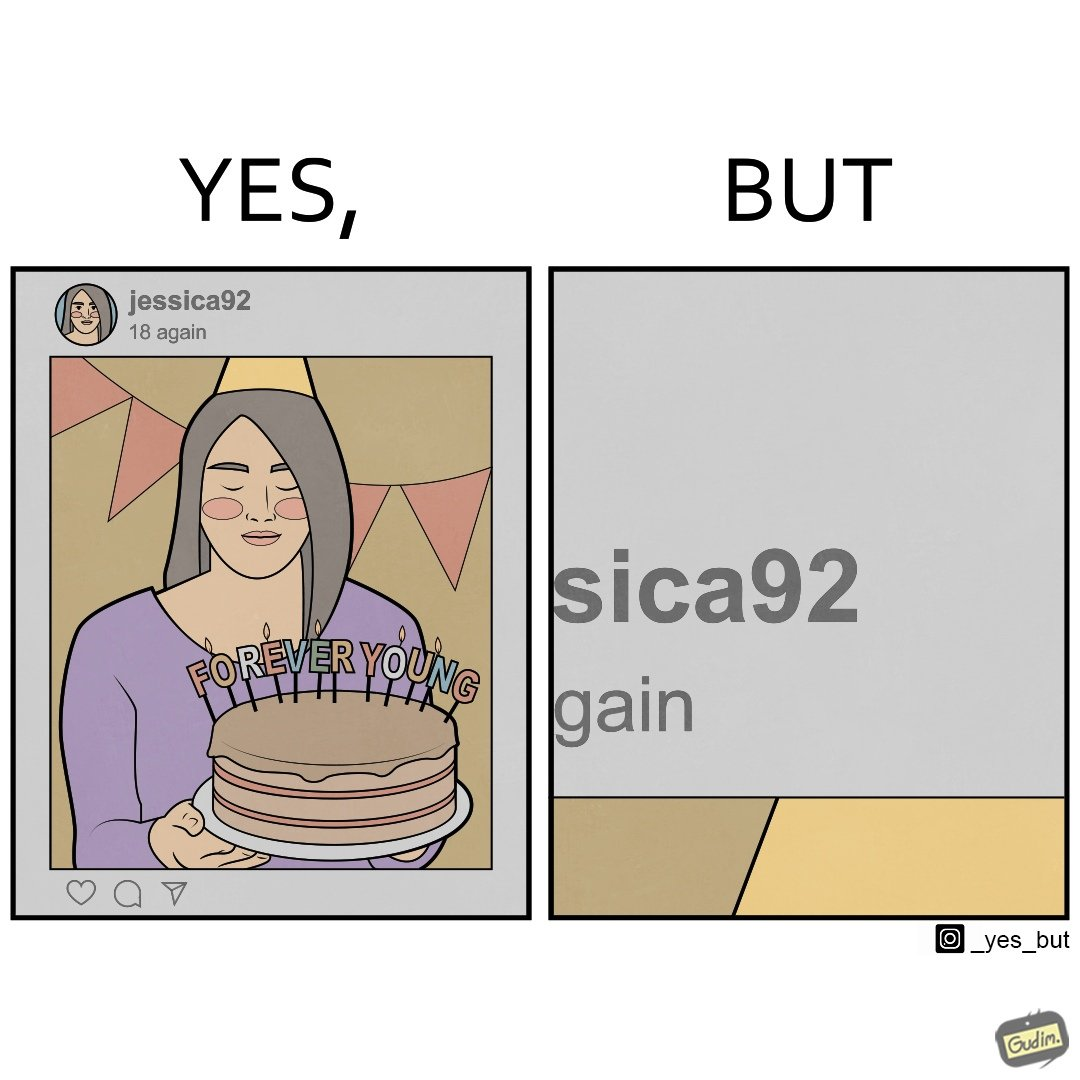What is shown in this image? The image is funny because while the woman claims she to be young, the likely year of her birth 1992 which can be inferred from her handle "jessica92" suggests that she is very old. 